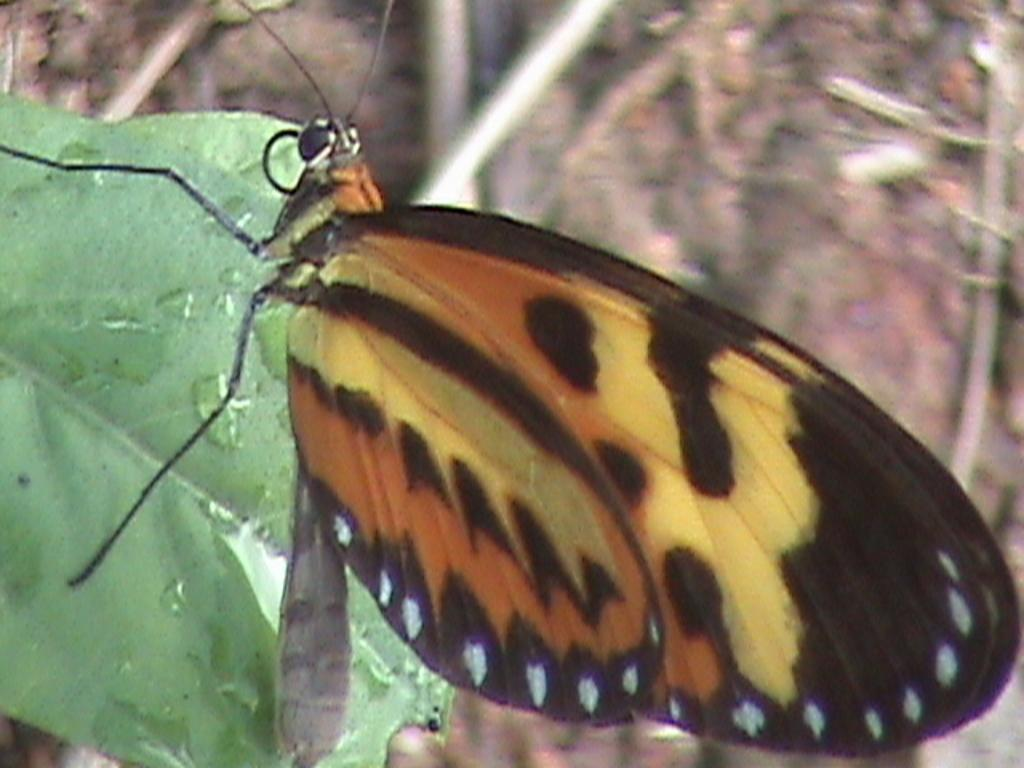What type of insect is present in the image? There is a butterfly in the image. Can you describe the color of the butterfly? The butterfly is black and brown in color. What can be seen on the left side of the image? There are leaves on the left side of the image. How many chairs are visible in the image? There are no chairs present in the image. What type of approval is required for the butterfly to fly in the image? The butterfly does not require any approval to fly in the image, as it is a natural occurrence. 